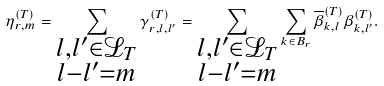<formula> <loc_0><loc_0><loc_500><loc_500>\eta _ { r , m } ^ { ( T ) } = \sum _ { \substack { l , l ^ { \prime } \in \mathcal { L } _ { T } \\ l - l ^ { \prime } = m } } \gamma _ { r , l , l ^ { \prime } } ^ { ( T ) } = \sum _ { \substack { l , l ^ { \prime } \in \mathcal { L } _ { T } \\ l - l ^ { \prime } = m } } \sum _ { k \in B _ { r } } \overline { \beta } _ { k , l } ^ { ( T ) } \beta _ { k , l ^ { \prime } } ^ { ( T ) } .</formula> 